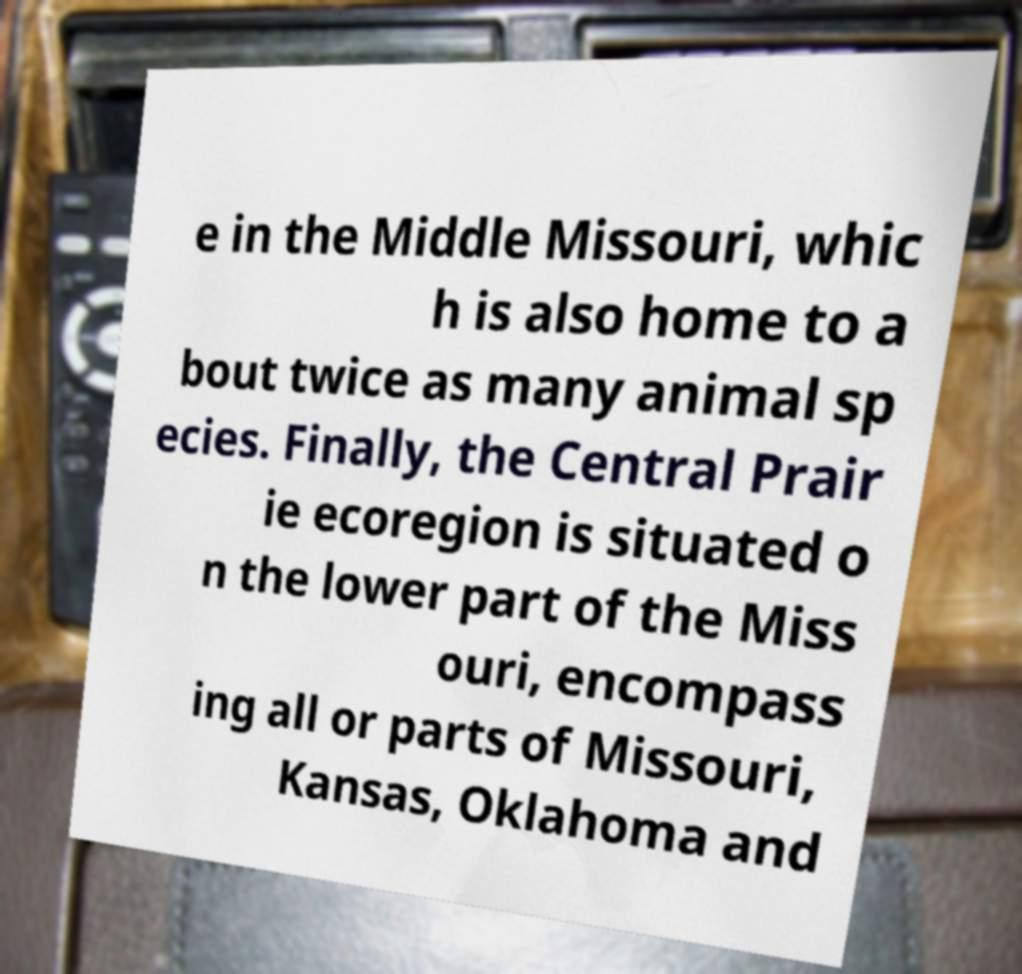There's text embedded in this image that I need extracted. Can you transcribe it verbatim? e in the Middle Missouri, whic h is also home to a bout twice as many animal sp ecies. Finally, the Central Prair ie ecoregion is situated o n the lower part of the Miss ouri, encompass ing all or parts of Missouri, Kansas, Oklahoma and 